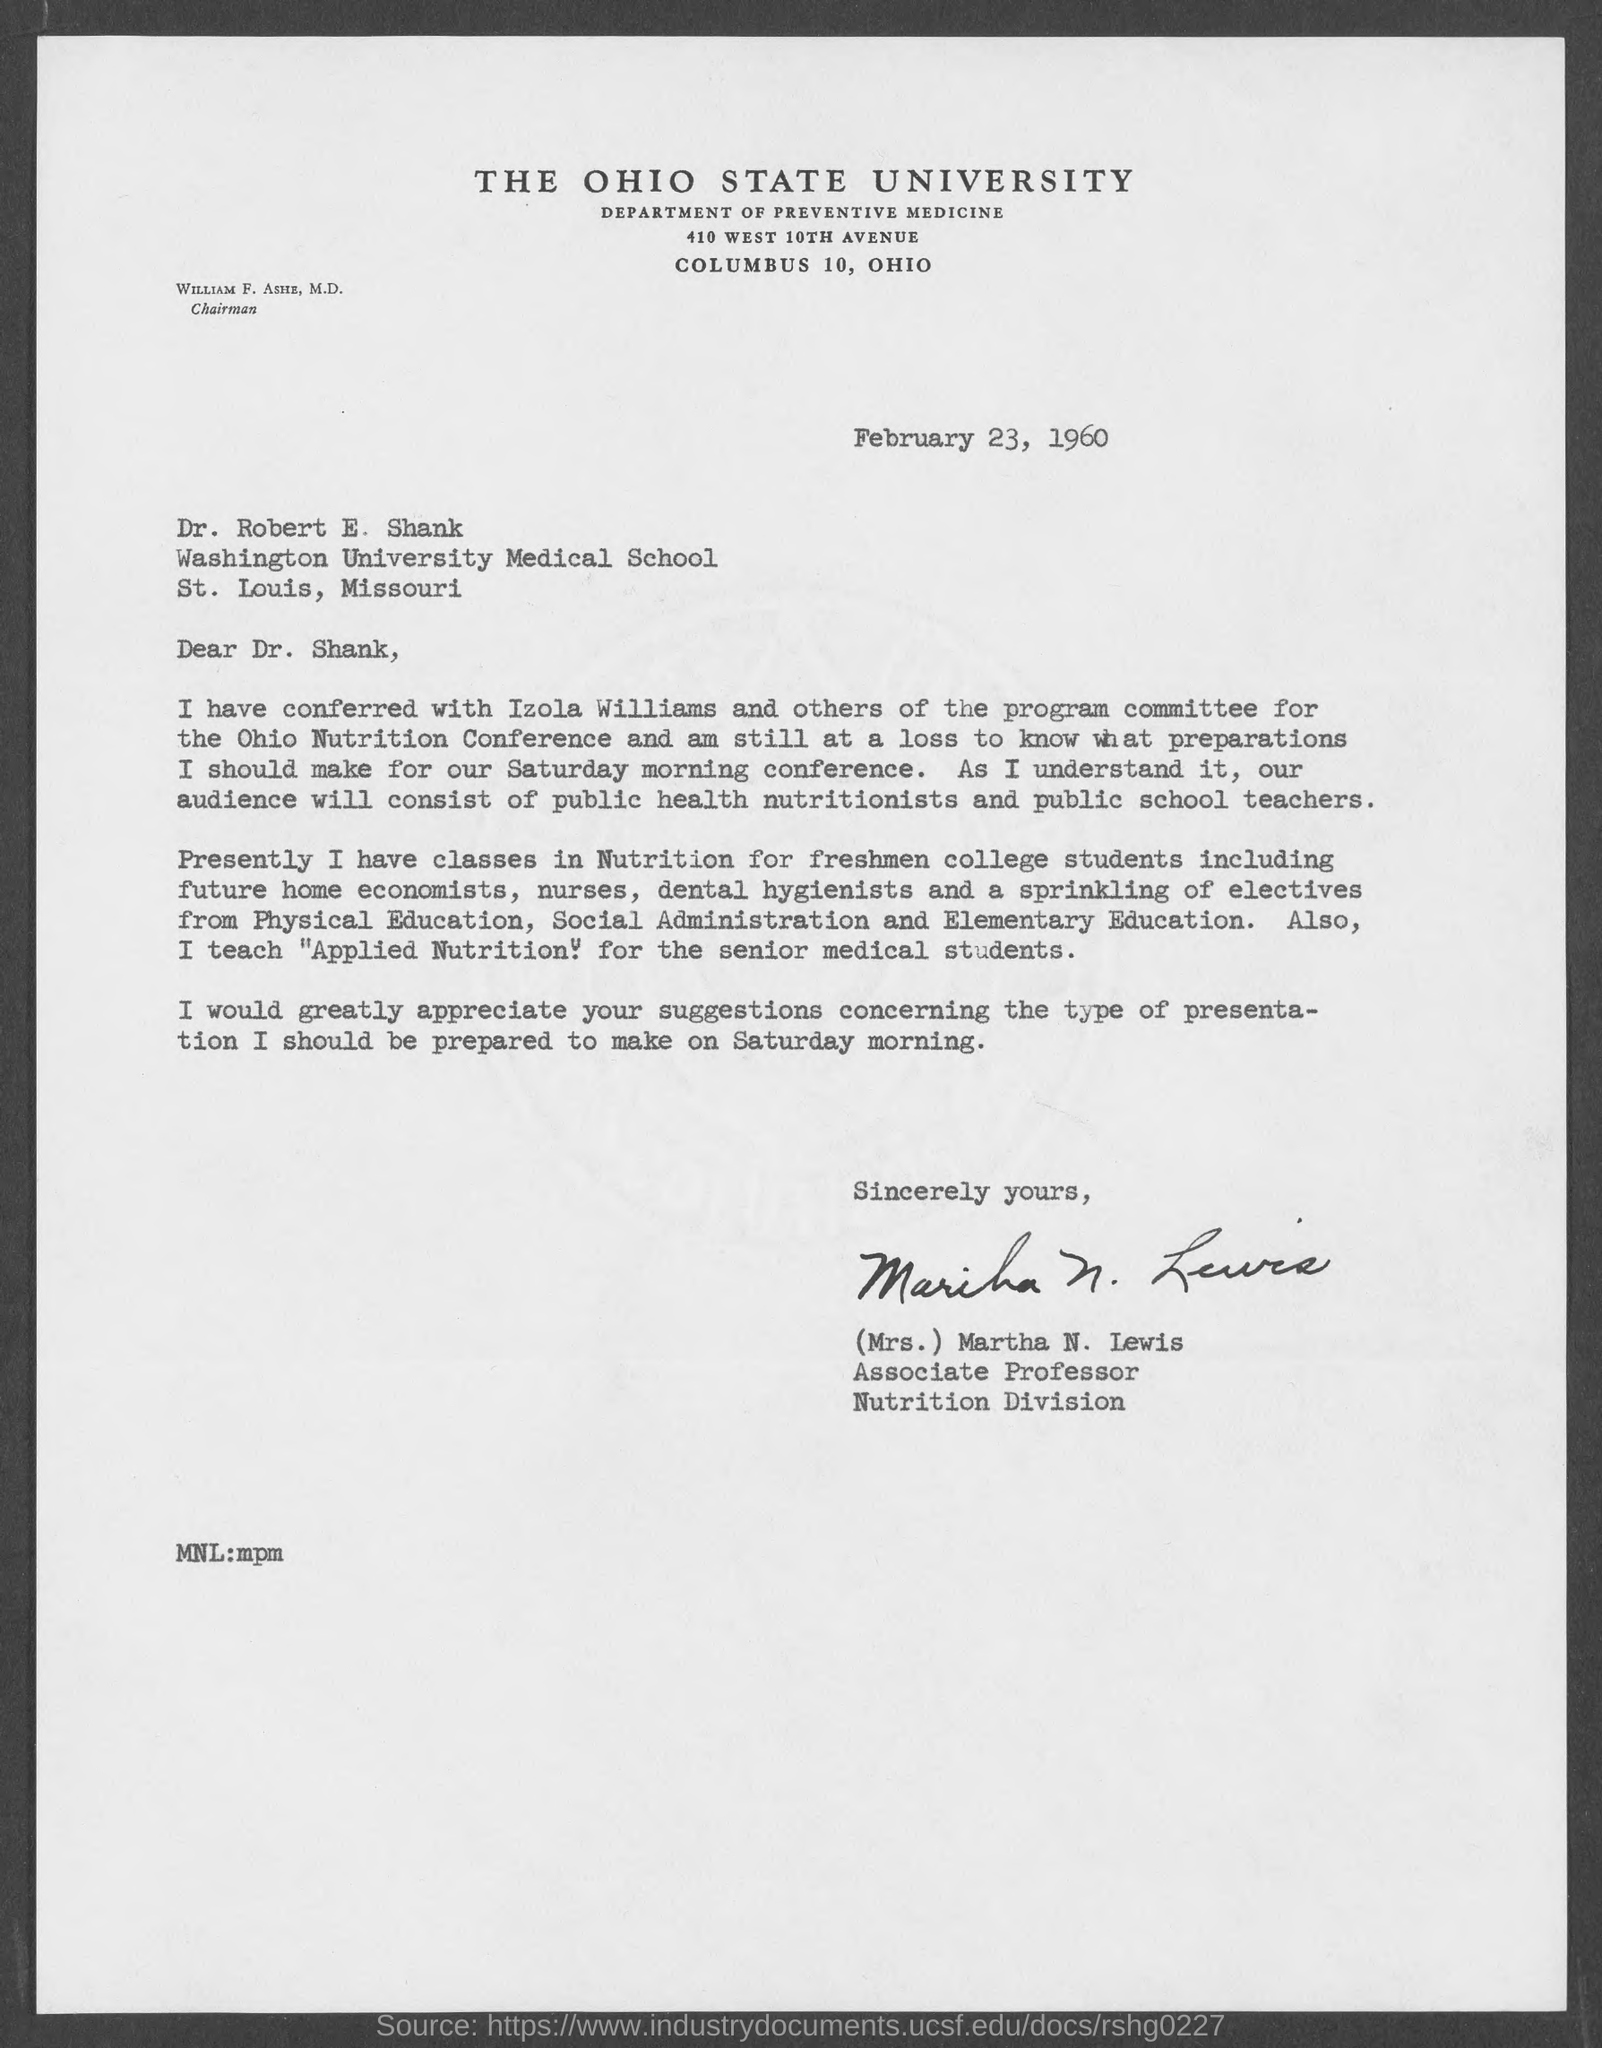Who is the Associate Professor ?
Ensure brevity in your answer.  (Mrs. ) Martha N. Lewis. Who is the Memorandum Addressed to ?
Make the answer very short. Dr. Robert E. Shank. 